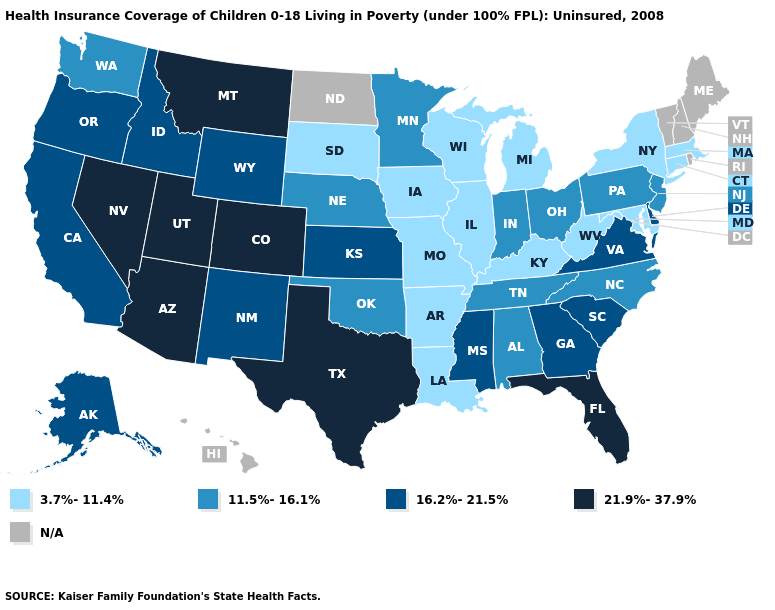Does the first symbol in the legend represent the smallest category?
Write a very short answer. Yes. Among the states that border Tennessee , does Arkansas have the lowest value?
Write a very short answer. Yes. Name the states that have a value in the range 11.5%-16.1%?
Short answer required. Alabama, Indiana, Minnesota, Nebraska, New Jersey, North Carolina, Ohio, Oklahoma, Pennsylvania, Tennessee, Washington. What is the highest value in the USA?
Short answer required. 21.9%-37.9%. Among the states that border Idaho , does Utah have the highest value?
Be succinct. Yes. Does Arkansas have the lowest value in the USA?
Be succinct. Yes. What is the lowest value in states that border Virginia?
Concise answer only. 3.7%-11.4%. Does Montana have the highest value in the West?
Quick response, please. Yes. Among the states that border Colorado , which have the highest value?
Keep it brief. Arizona, Utah. What is the highest value in the West ?
Keep it brief. 21.9%-37.9%. Is the legend a continuous bar?
Answer briefly. No. Does the map have missing data?
Keep it brief. Yes. Name the states that have a value in the range 11.5%-16.1%?
Give a very brief answer. Alabama, Indiana, Minnesota, Nebraska, New Jersey, North Carolina, Ohio, Oklahoma, Pennsylvania, Tennessee, Washington. What is the lowest value in states that border North Carolina?
Be succinct. 11.5%-16.1%. 